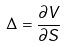<formula> <loc_0><loc_0><loc_500><loc_500>\Delta = \frac { \partial V } { \partial S }</formula> 